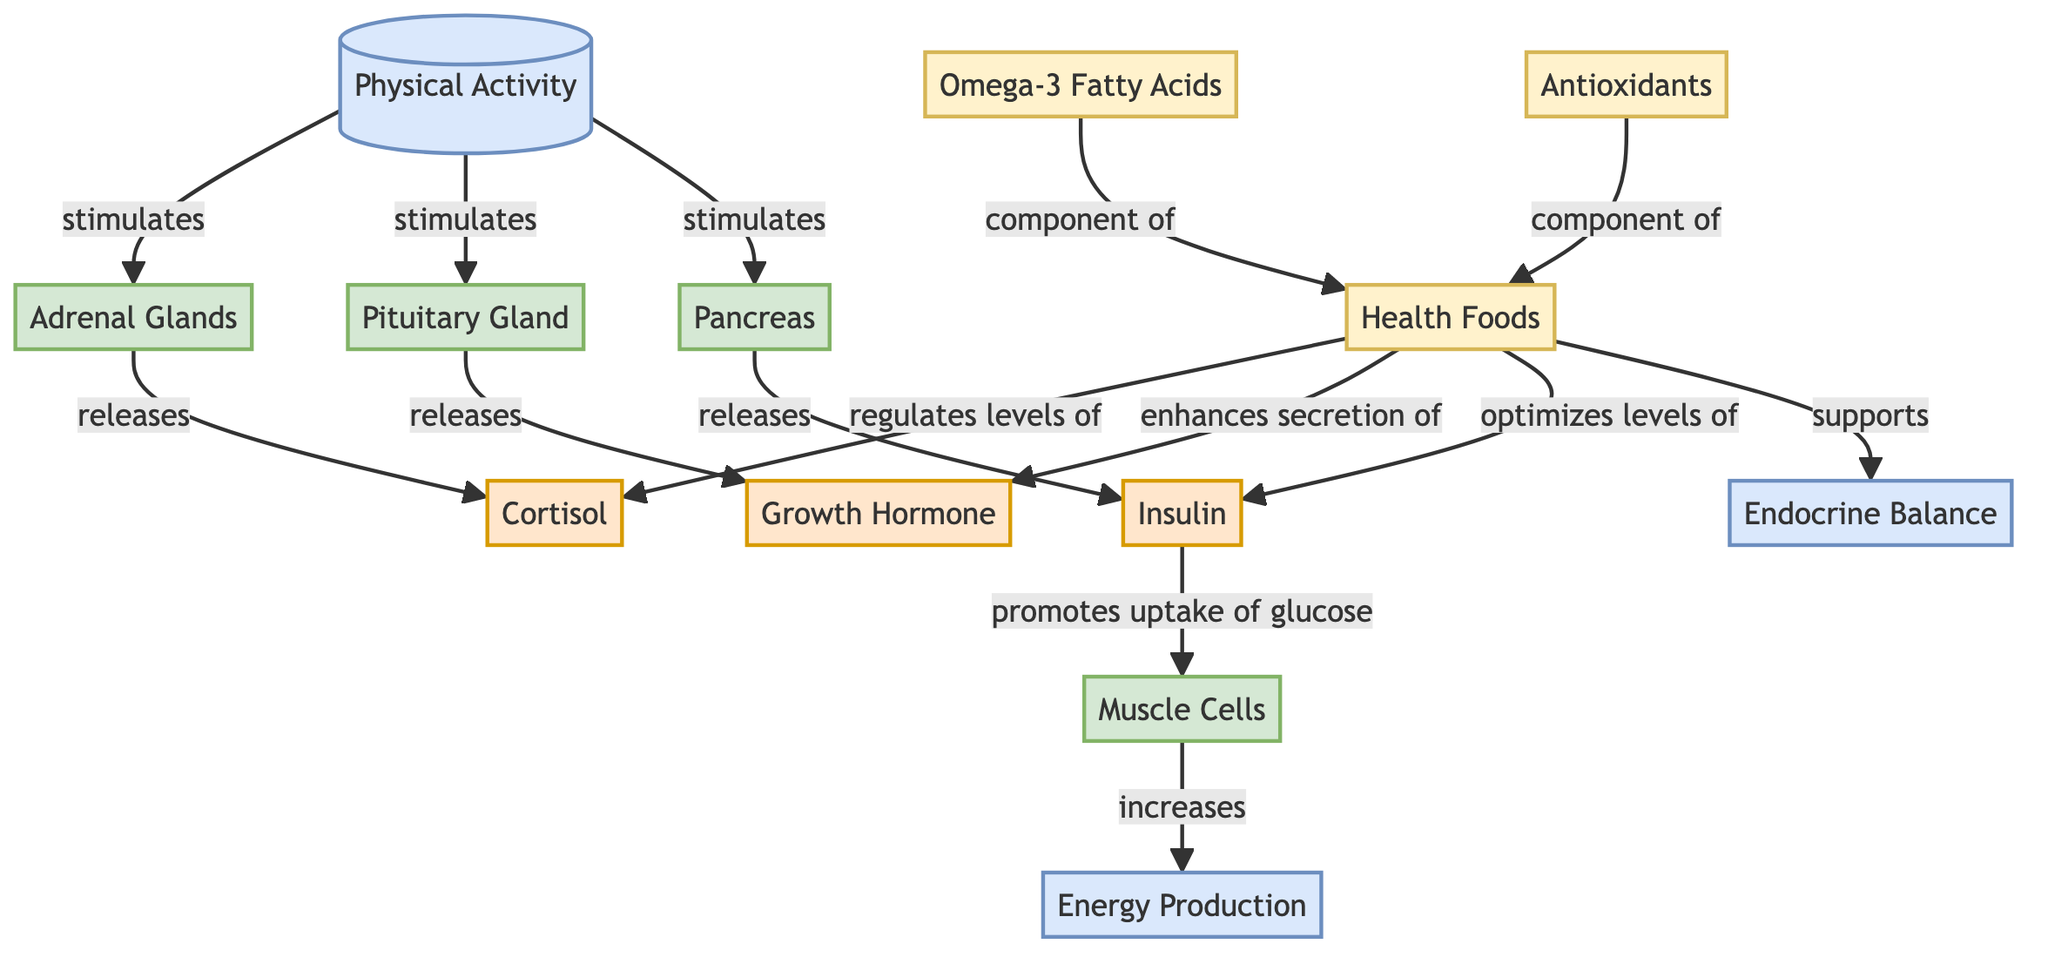What initiates the hormonal changes in the diagram? The starting point of the diagram, labeled "Physical Activity," indicates that it is the event that stimulates the release of hormones from various glands. This relationship illustrates how physical activity triggers hormonal regulation.
Answer: Physical Activity Which hormone is released by the adrenal glands? The diagram shows that the adrenal glands release "Cortisol" as indicated by the directional flow line connecting the adrenal glands to the cortisol node.
Answer: Cortisol How many organs are represented in the diagram? Observing the diagram reveals four distinct organs: Adrenal Glands, Pituitary Gland, Pancreas, and Muscle Cells, each identified as an organ node.
Answer: 4 What is the role of insulin in the diagram? According to the diagram, insulin is released by the pancreas and has the specific role of promoting the uptake of glucose by muscle cells, evidenced by the flow from the pancreas to insulin and then to muscle cells.
Answer: Promotes uptake of glucose How do health foods affect cortisol levels? The diagram details that health foods regulate levels of cortisol, linking the health foods node to the cortisol node, showing that health foods have a direct influence on hormone equilibrium.
Answer: Regulates levels of cortisol What components of health foods are indicated in the diagram? The diagram explicitly states that "Omega-3 Fatty Acids" and "Antioxidants" are components of health foods, which connects them to the health foods node in the diagram.
Answer: Omega-3 Fatty Acids, Antioxidants What final process is supported by health foods? The diagram indicates that health foods support "Endocrine Balance," linking the health foods node directly to the endocrine balance node, summarizing their role in physiological stability.
Answer: Endocrine Balance Which gland releases growth hormone? The diagram clearly shows that the "Pituitary Gland" is responsible for releasing the "Growth Hormone," with a direct flow from the pituitary gland to growth hormone.
Answer: Pituitary Gland What is the overall role of energy production in relation to physical activity? The diagram establishes that as a consequence of increased glucose uptake by muscle cells, there is an increase in energy production, linking these processes in the flow from muscle cells to energy production.
Answer: Increases 